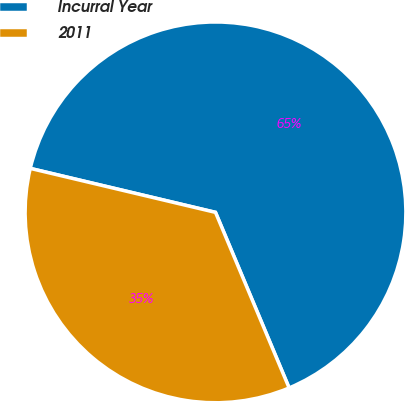Convert chart. <chart><loc_0><loc_0><loc_500><loc_500><pie_chart><fcel>Incurral Year<fcel>2011<nl><fcel>64.97%<fcel>35.03%<nl></chart> 